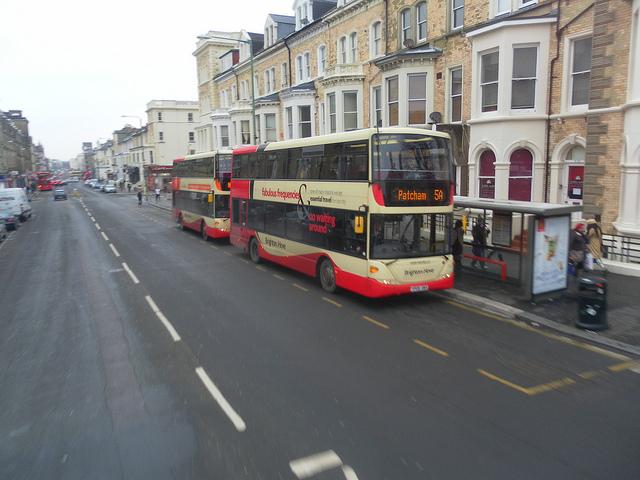How many people are at the bus stop?
Write a very short answer. 2. Is there a red car in the picture?
Be succinct. No. How many buses are there?
Write a very short answer. 2. Is this a bus stop?
Answer briefly. Yes. 